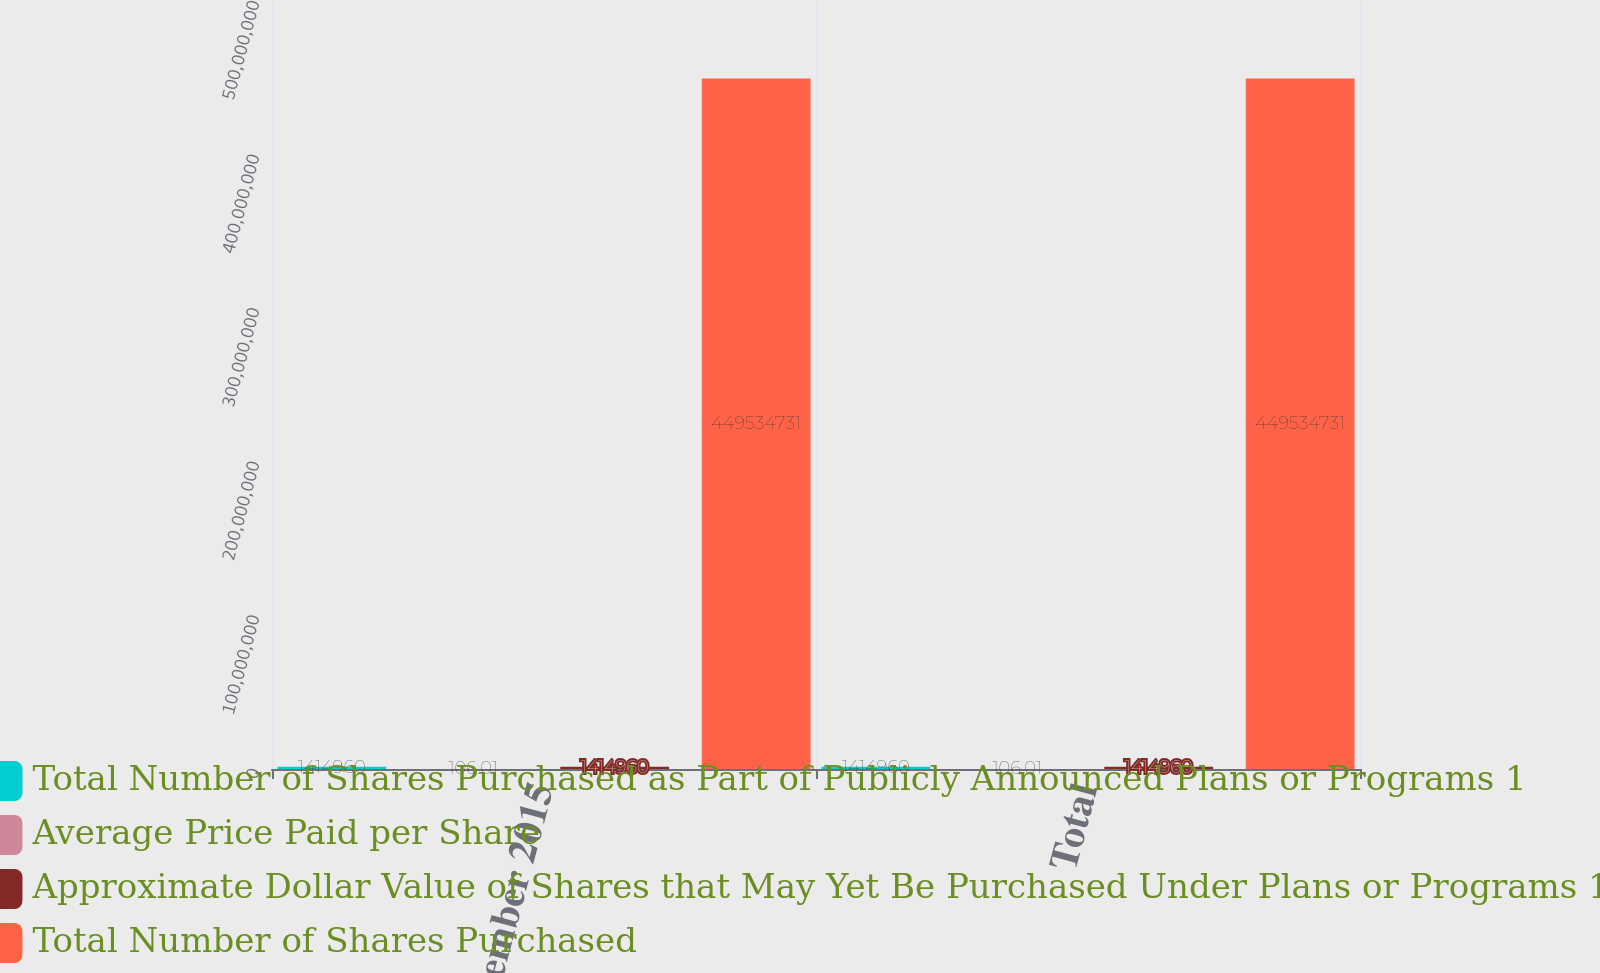Convert chart to OTSL. <chart><loc_0><loc_0><loc_500><loc_500><stacked_bar_chart><ecel><fcel>November 2015<fcel>Total<nl><fcel>Total Number of Shares Purchased as Part of Publicly Announced Plans or Programs 1<fcel>1.41496e+06<fcel>1.41496e+06<nl><fcel>Average Price Paid per Share<fcel>106.01<fcel>106.01<nl><fcel>Approximate Dollar Value of Shares that May Yet Be Purchased Under Plans or Programs 1<fcel>1.41496e+06<fcel>1.41496e+06<nl><fcel>Total Number of Shares Purchased<fcel>4.49535e+08<fcel>4.49535e+08<nl></chart> 